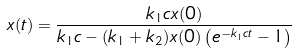Convert formula to latex. <formula><loc_0><loc_0><loc_500><loc_500>x ( t ) = \frac { k _ { 1 } c x ( 0 ) } { k _ { 1 } c - ( k _ { 1 } + k _ { 2 } ) x ( 0 ) \left ( e ^ { - k _ { 1 } c t } - 1 \right ) }</formula> 